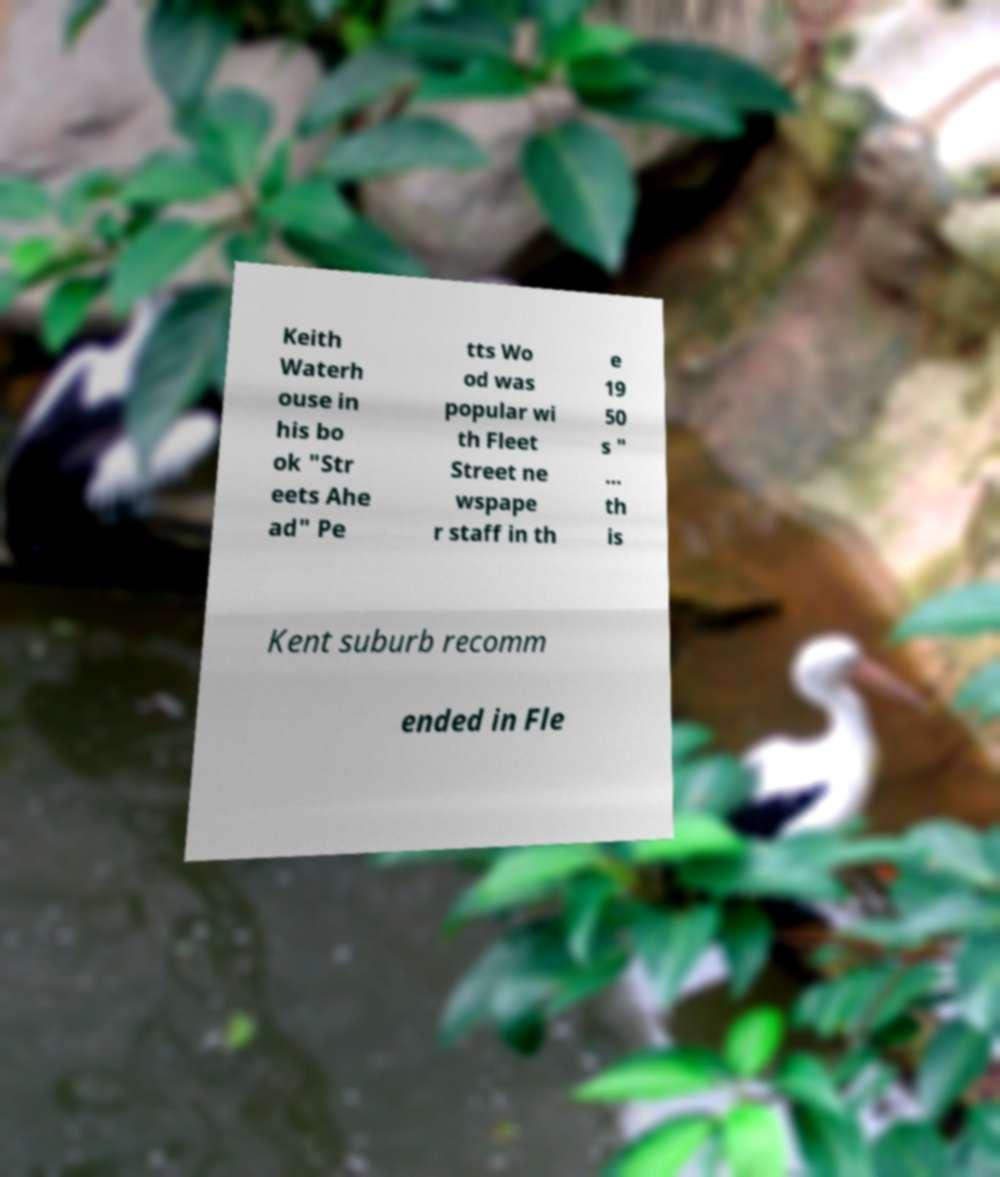Please read and relay the text visible in this image. What does it say? Keith Waterh ouse in his bo ok "Str eets Ahe ad" Pe tts Wo od was popular wi th Fleet Street ne wspape r staff in th e 19 50 s " … th is Kent suburb recomm ended in Fle 